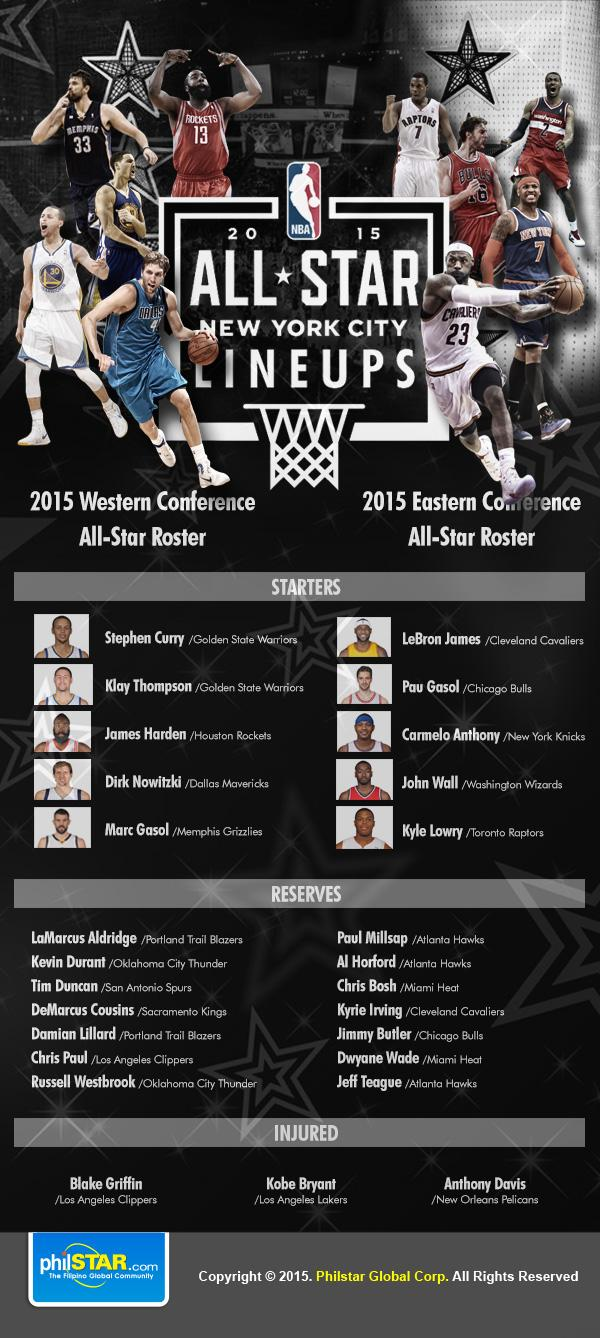Identify some key points in this picture. It is reported that 3 individuals have sustained injuries. The Golden State Warriors have two starters on their team. The Miami Heat has two reserve players. The Atlanta Hawks team has three reserves. The names of reserve players from the Atlanta Hawks team are Paul Millsap, Al Horford, and Jeff Teague. 